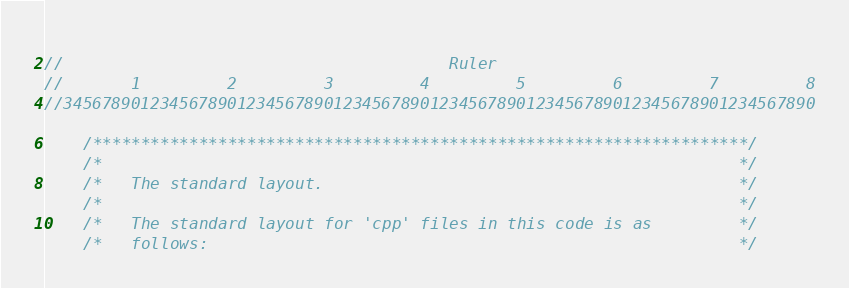<code> <loc_0><loc_0><loc_500><loc_500><_C++_>                          
//                                        Ruler
//       1         2         3         4         5         6         7         8
//345678901234567890123456789012345678901234567890123456789012345678901234567890

    /********************************************************************/
    /*                                                                  */
    /*   The standard layout.                                           */
    /*                                                                  */
    /*   The standard layout for 'cpp' files in this code is as         */
    /*   follows:                                                       */</code> 